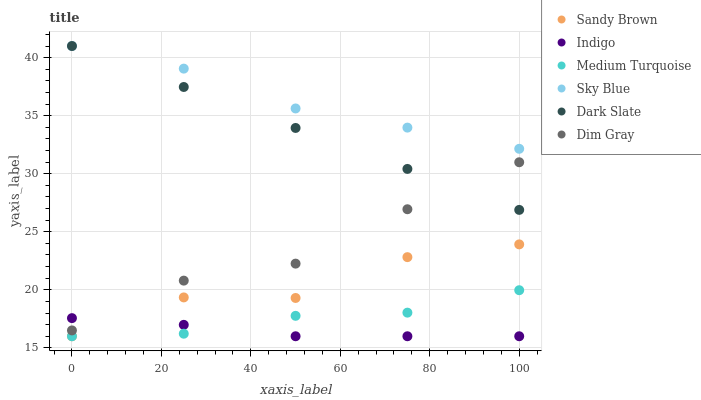Does Indigo have the minimum area under the curve?
Answer yes or no. Yes. Does Sky Blue have the maximum area under the curve?
Answer yes or no. Yes. Does Dark Slate have the minimum area under the curve?
Answer yes or no. No. Does Dark Slate have the maximum area under the curve?
Answer yes or no. No. Is Dark Slate the smoothest?
Answer yes or no. Yes. Is Sandy Brown the roughest?
Answer yes or no. Yes. Is Indigo the smoothest?
Answer yes or no. No. Is Indigo the roughest?
Answer yes or no. No. Does Indigo have the lowest value?
Answer yes or no. Yes. Does Dark Slate have the lowest value?
Answer yes or no. No. Does Sky Blue have the highest value?
Answer yes or no. Yes. Does Indigo have the highest value?
Answer yes or no. No. Is Medium Turquoise less than Dark Slate?
Answer yes or no. Yes. Is Sky Blue greater than Dim Gray?
Answer yes or no. Yes. Does Dark Slate intersect Sky Blue?
Answer yes or no. Yes. Is Dark Slate less than Sky Blue?
Answer yes or no. No. Is Dark Slate greater than Sky Blue?
Answer yes or no. No. Does Medium Turquoise intersect Dark Slate?
Answer yes or no. No. 